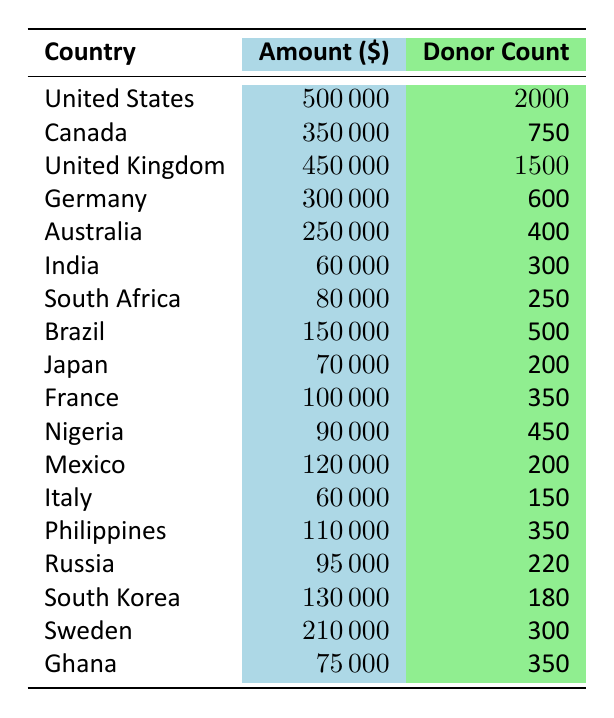What is the total amount of donations received from the United States? The table shows that the donation amount from the United States is \$500,000.
Answer: 500000 Which country has the highest number of donors? The table indicates that the United States has the highest donor count with 2,000 donors.
Answer: United States What are the donation amounts for the top three countries by amount? The amounts are \$500,000 for the United States, \$450,000 for the United Kingdom, and \$350,000 for Canada.
Answer: 500000, 450000, 350000 How many donors contributed to projects in Germany? The table specifies that there are 600 donors for the project in Germany.
Answer: 600 What is the total amount of donations received from Canada and Australia? The total is calculated by adding Canada's \$350,000 and Australia's \$250,000, resulting in \$600,000.
Answer: 600000 Is the total amount of donations from India greater than that from Japan? The donation from India is \$60,000 and from Japan is \$70,000. So, the statement is false.
Answer: No What is the average donation amount from the countries listed? The total amount is \(500000 + 350000 + 450000 + 300000 + 250000 + 60000 + 80000 + 150000 + 70000 + 100000 + 90000 + 120000 + 60000 + 110000 + 95000 + 130000 + 210000 + 75000\) = \$2,138,000 and there are 18 countries, so the average is \$2,138,000 / 18 = \$118,777.78.
Answer: 118777.78 What is the difference between the highest and lowest donation amounts? The highest amount is from the United States at \$500,000 and the lowest is from India at \$60,000. The difference is \$500,000 - \$60,000 = \$440,000.
Answer: 440000 Which project type received the least total donations? Analyzing the project amounts, Youth Empowerment in India received the least at \$60,000.
Answer: Youth Empowerment How many countries have donations above \$100,000? The countries with donations above \$100,000 are: United States, United Kingdom, Canada, Germany, Australia, Brazil, Mexico, South Korea, and Sweden, totaling 9 countries.
Answer: 9 Is the total donation count from France and Brazil greater than from South Africa and Ghana combined? The total donations from France and Brazil are \(100000 + 150000 = 250000\), while the total from South Africa and Ghana is \(80000 + 75000 = 155000\). Since 250000 > 155000, the statement is true.
Answer: Yes 